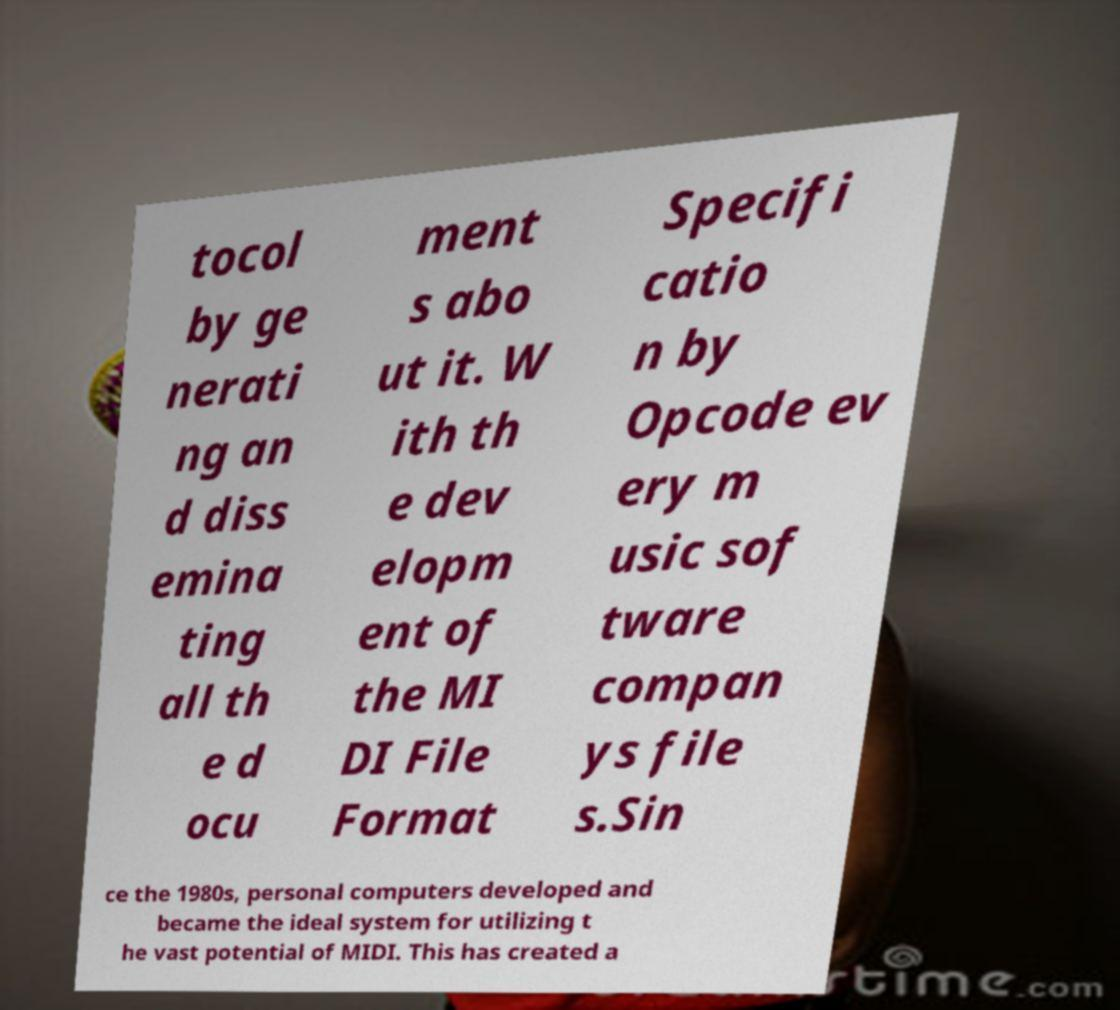For documentation purposes, I need the text within this image transcribed. Could you provide that? tocol by ge nerati ng an d diss emina ting all th e d ocu ment s abo ut it. W ith th e dev elopm ent of the MI DI File Format Specifi catio n by Opcode ev ery m usic sof tware compan ys file s.Sin ce the 1980s, personal computers developed and became the ideal system for utilizing t he vast potential of MIDI. This has created a 